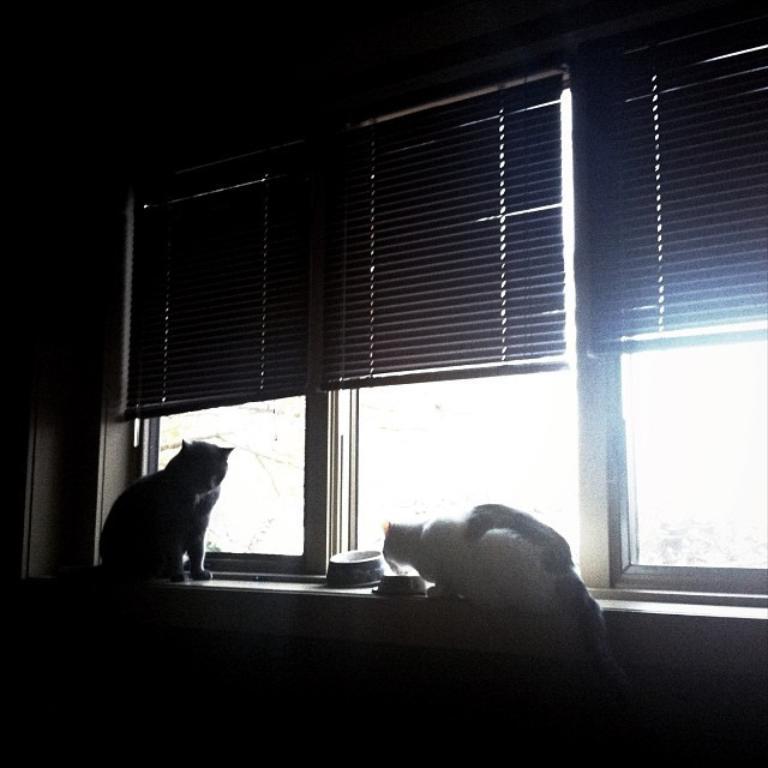Please provide a concise description of this image. In this picture I can observe two cats on the desk. There is a curtain and windows. The room is dark. 